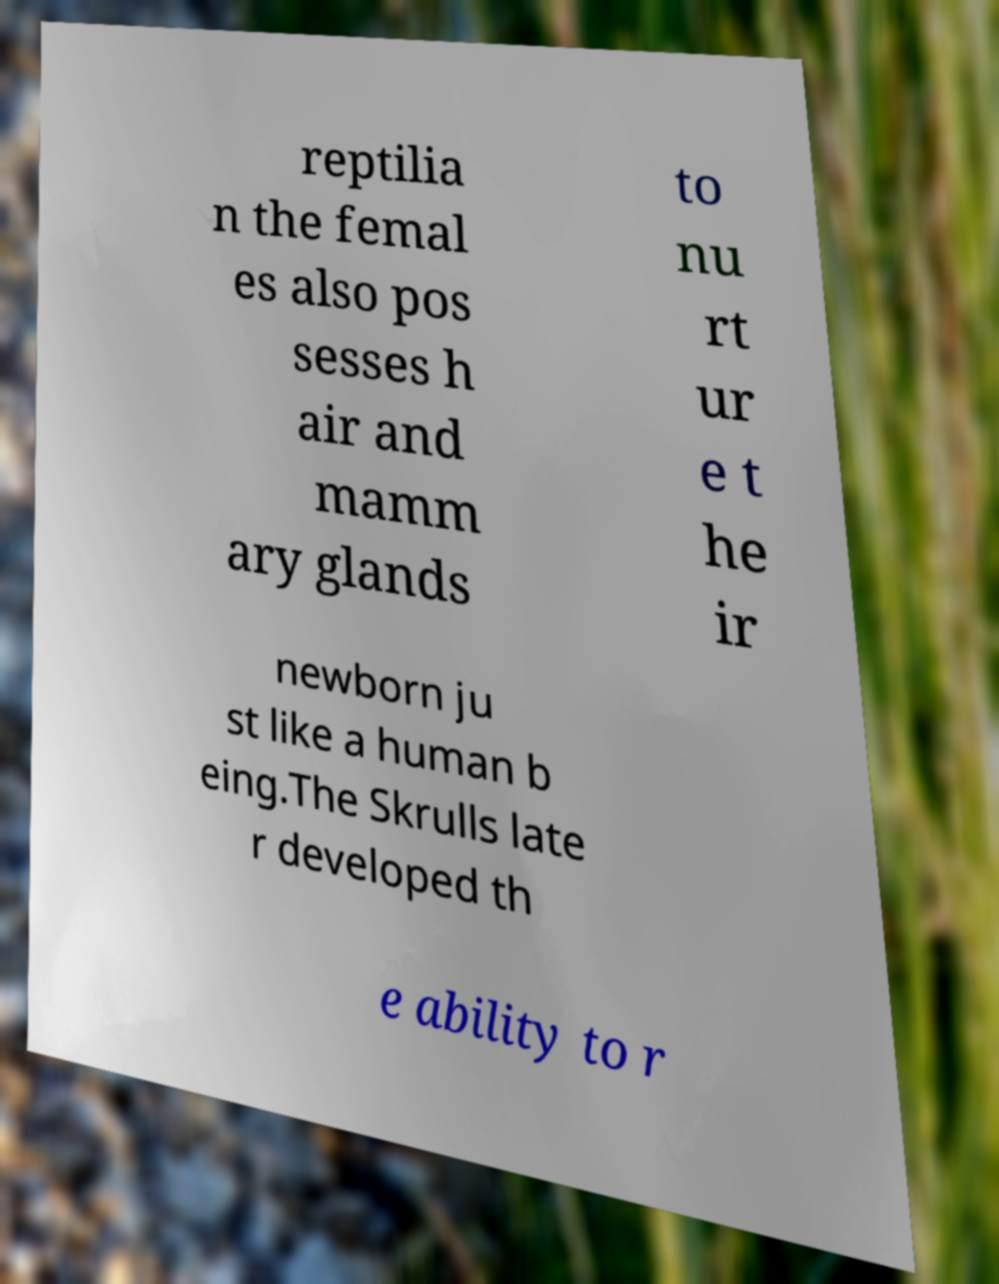Can you accurately transcribe the text from the provided image for me? reptilia n the femal es also pos sesses h air and mamm ary glands to nu rt ur e t he ir newborn ju st like a human b eing.The Skrulls late r developed th e ability to r 